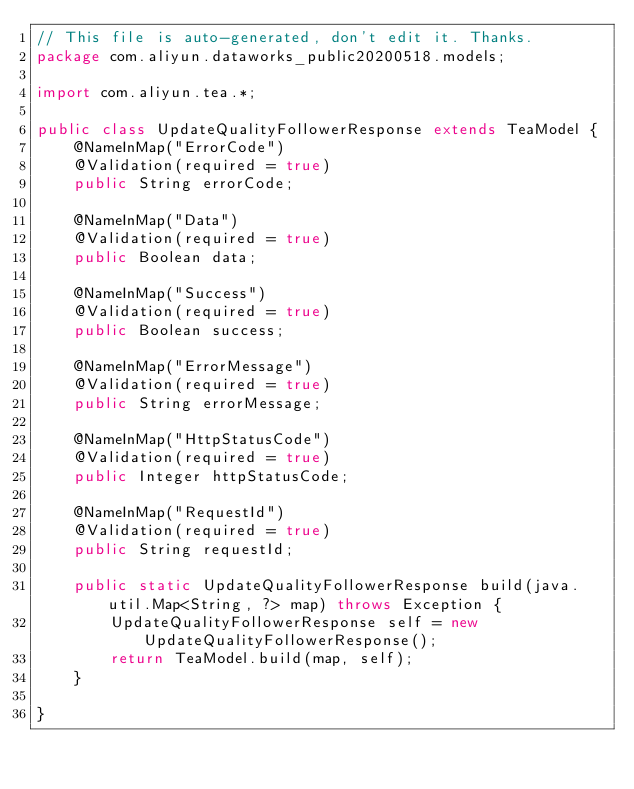<code> <loc_0><loc_0><loc_500><loc_500><_Java_>// This file is auto-generated, don't edit it. Thanks.
package com.aliyun.dataworks_public20200518.models;

import com.aliyun.tea.*;

public class UpdateQualityFollowerResponse extends TeaModel {
    @NameInMap("ErrorCode")
    @Validation(required = true)
    public String errorCode;

    @NameInMap("Data")
    @Validation(required = true)
    public Boolean data;

    @NameInMap("Success")
    @Validation(required = true)
    public Boolean success;

    @NameInMap("ErrorMessage")
    @Validation(required = true)
    public String errorMessage;

    @NameInMap("HttpStatusCode")
    @Validation(required = true)
    public Integer httpStatusCode;

    @NameInMap("RequestId")
    @Validation(required = true)
    public String requestId;

    public static UpdateQualityFollowerResponse build(java.util.Map<String, ?> map) throws Exception {
        UpdateQualityFollowerResponse self = new UpdateQualityFollowerResponse();
        return TeaModel.build(map, self);
    }

}
</code> 